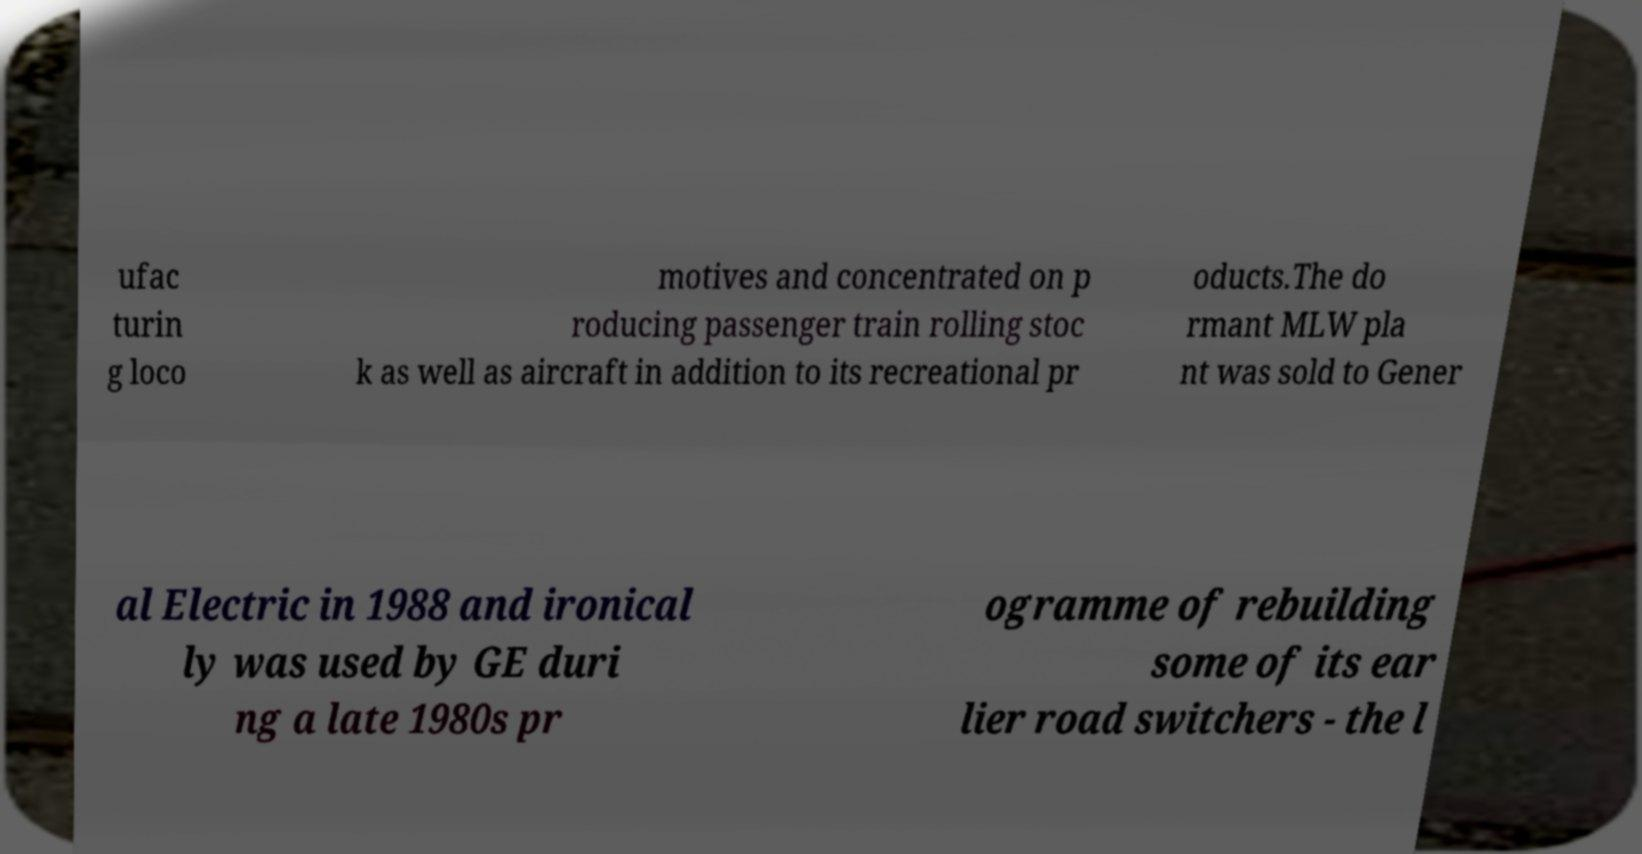Can you read and provide the text displayed in the image?This photo seems to have some interesting text. Can you extract and type it out for me? ufac turin g loco motives and concentrated on p roducing passenger train rolling stoc k as well as aircraft in addition to its recreational pr oducts.The do rmant MLW pla nt was sold to Gener al Electric in 1988 and ironical ly was used by GE duri ng a late 1980s pr ogramme of rebuilding some of its ear lier road switchers - the l 